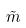Convert formula to latex. <formula><loc_0><loc_0><loc_500><loc_500>\tilde { m }</formula> 